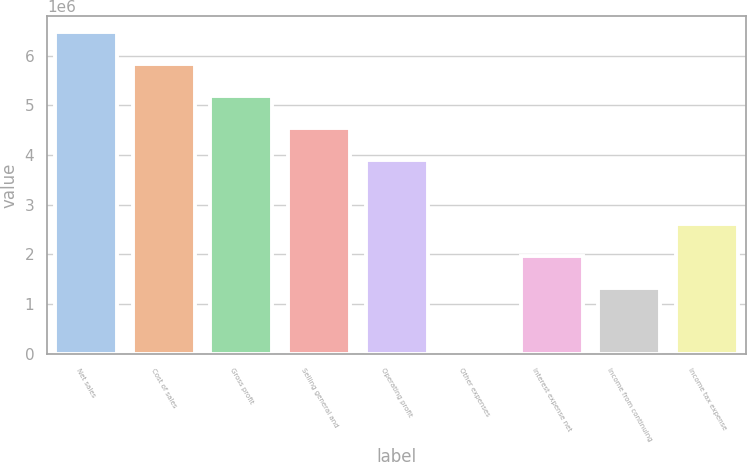Convert chart to OTSL. <chart><loc_0><loc_0><loc_500><loc_500><bar_chart><fcel>Net sales<fcel>Cost of sales<fcel>Gross profit<fcel>Selling general and<fcel>Operating profit<fcel>Other expenses<fcel>Interest expense net<fcel>Income from continuing<fcel>Income tax expense<nl><fcel>6.47141e+06<fcel>5.82753e+06<fcel>5.18366e+06<fcel>4.53978e+06<fcel>3.8959e+06<fcel>32645<fcel>1.96427e+06<fcel>1.3204e+06<fcel>2.60815e+06<nl></chart> 